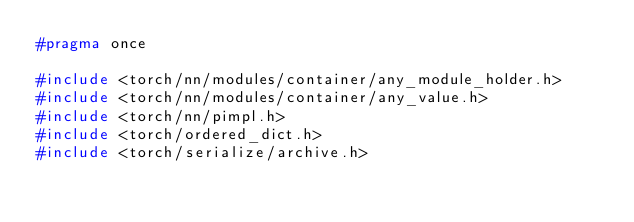Convert code to text. <code><loc_0><loc_0><loc_500><loc_500><_C_>#pragma once

#include <torch/nn/modules/container/any_module_holder.h>
#include <torch/nn/modules/container/any_value.h>
#include <torch/nn/pimpl.h>
#include <torch/ordered_dict.h>
#include <torch/serialize/archive.h></code> 